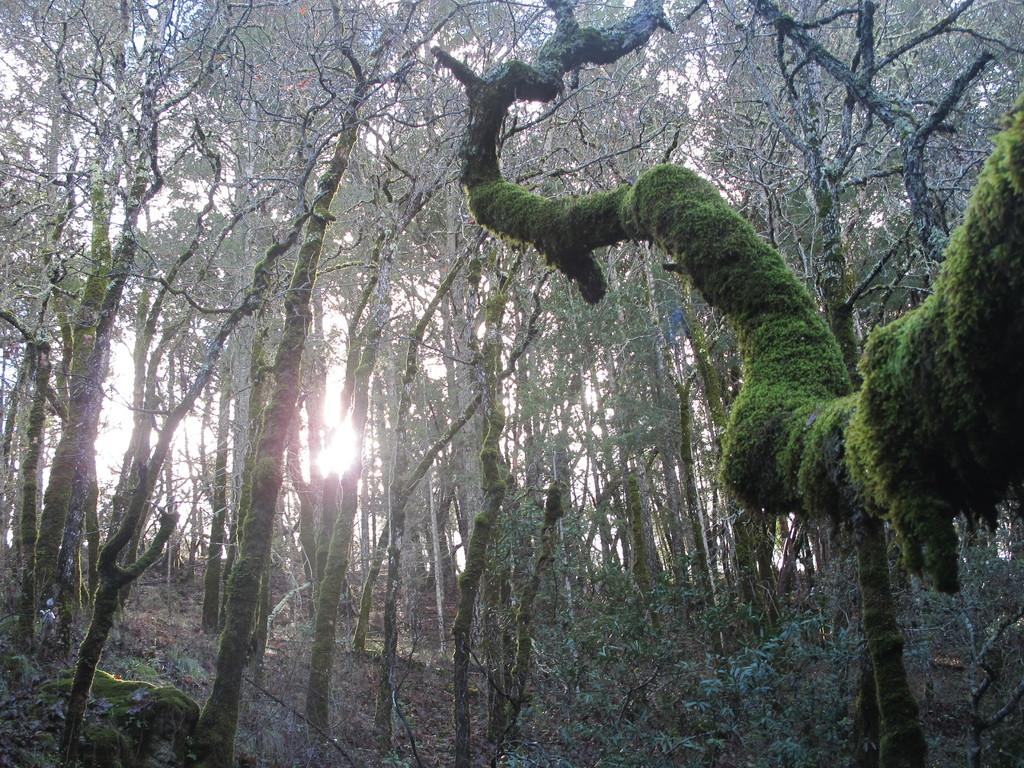What type of vegetation can be seen in the image? There are trees and plants in the image. What is visible beneath the vegetation in the image? The ground is visible in the image. What is visible above the vegetation in the image? The sky is visible in the image. Can you see a cannon hidden among the trees in the image? There is no cannon present in the image; it only features trees, plants, the ground, and the sky. 